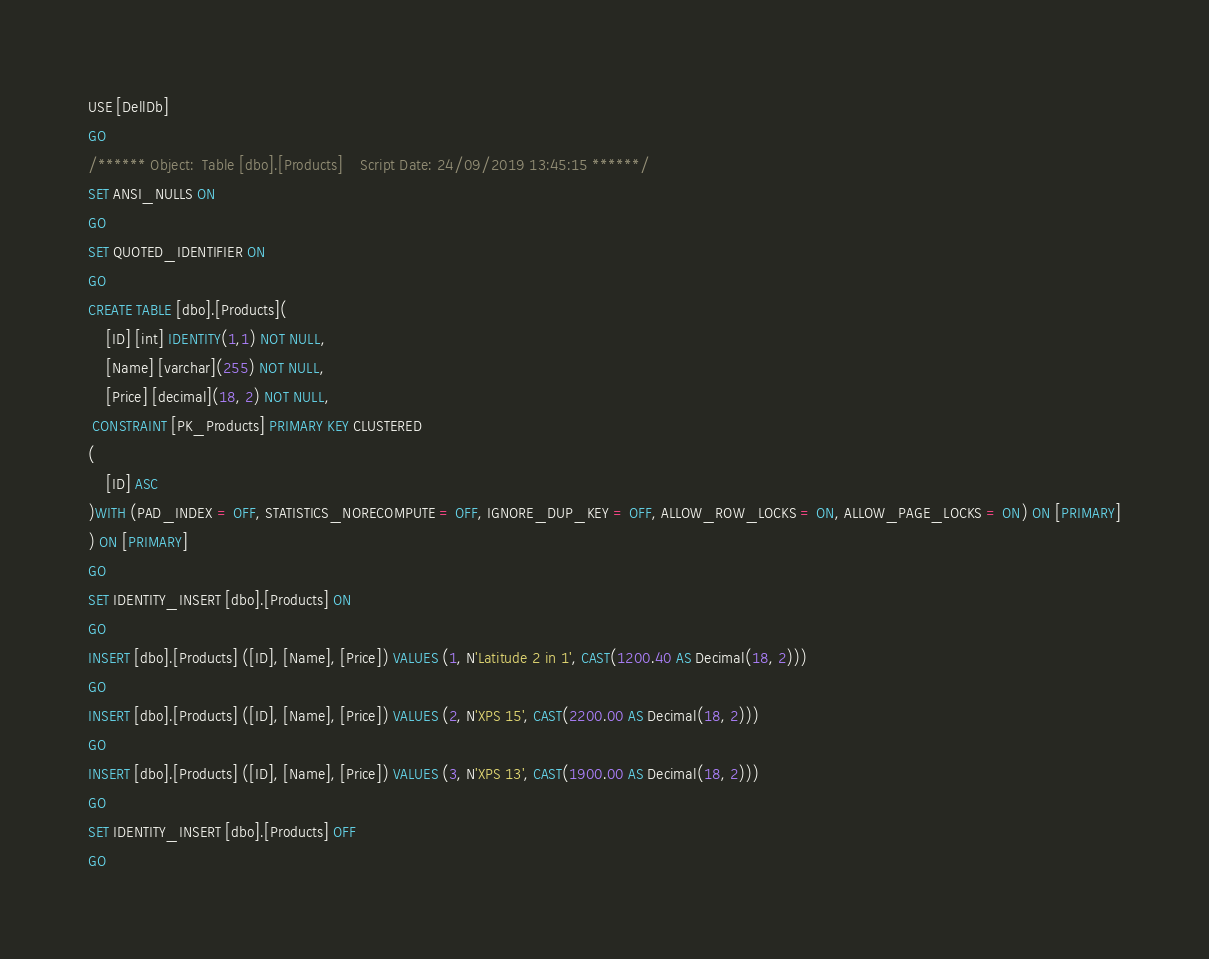Convert code to text. <code><loc_0><loc_0><loc_500><loc_500><_SQL_>USE [DellDb]
GO
/****** Object:  Table [dbo].[Products]    Script Date: 24/09/2019 13:45:15 ******/
SET ANSI_NULLS ON
GO
SET QUOTED_IDENTIFIER ON
GO
CREATE TABLE [dbo].[Products](
	[ID] [int] IDENTITY(1,1) NOT NULL,
	[Name] [varchar](255) NOT NULL,
	[Price] [decimal](18, 2) NOT NULL,
 CONSTRAINT [PK_Products] PRIMARY KEY CLUSTERED 
(
	[ID] ASC
)WITH (PAD_INDEX = OFF, STATISTICS_NORECOMPUTE = OFF, IGNORE_DUP_KEY = OFF, ALLOW_ROW_LOCKS = ON, ALLOW_PAGE_LOCKS = ON) ON [PRIMARY]
) ON [PRIMARY]
GO
SET IDENTITY_INSERT [dbo].[Products] ON 
GO
INSERT [dbo].[Products] ([ID], [Name], [Price]) VALUES (1, N'Latitude 2 in 1', CAST(1200.40 AS Decimal(18, 2)))
GO
INSERT [dbo].[Products] ([ID], [Name], [Price]) VALUES (2, N'XPS 15', CAST(2200.00 AS Decimal(18, 2)))
GO
INSERT [dbo].[Products] ([ID], [Name], [Price]) VALUES (3, N'XPS 13', CAST(1900.00 AS Decimal(18, 2)))
GO
SET IDENTITY_INSERT [dbo].[Products] OFF
GO
</code> 